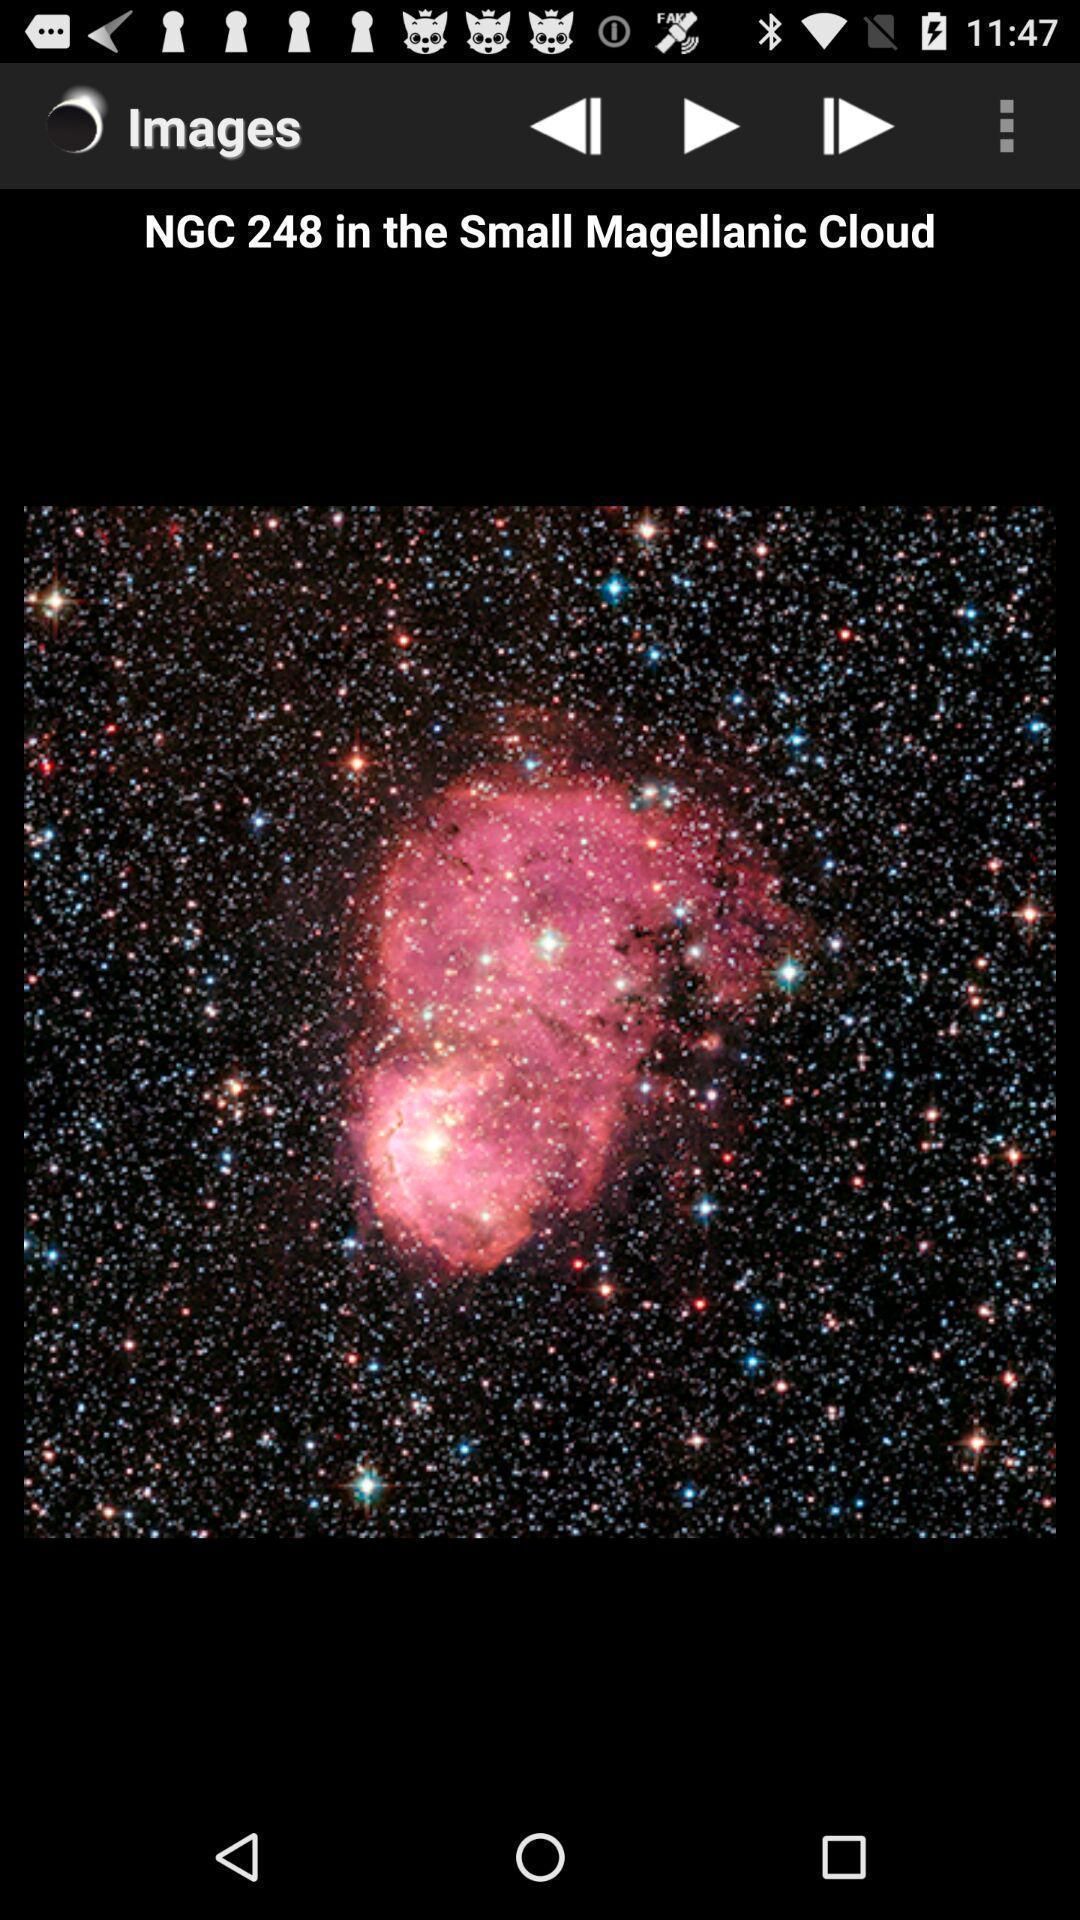Summarize the information in this screenshot. Small magellanic cloud in the image. 